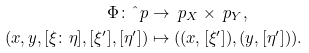Convert formula to latex. <formula><loc_0><loc_0><loc_500><loc_500>\Phi \colon \hat { \ } p & \to \ p _ { X } \times \ p _ { Y } , \\ ( x , y , [ \xi \colon \eta ] , [ \xi ^ { \prime } ] , [ \eta ^ { \prime } ] ) & \mapsto ( ( x , [ \xi ^ { \prime } ] ) , ( y , [ \eta ^ { \prime } ] ) ) .</formula> 